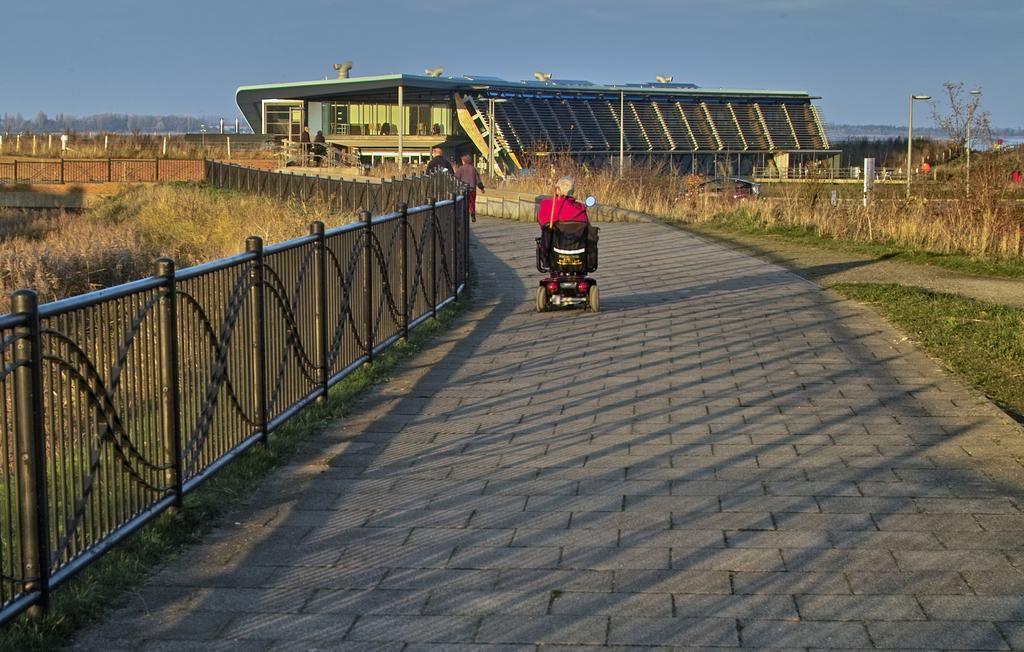Could you give a brief overview of what you see in this image? In this image, in the middle there is a vehicle, on that there is a person. On the left there are railing, grass. In the background there are people, building, vehicles, poles, trees, grassland, floor, sky. 